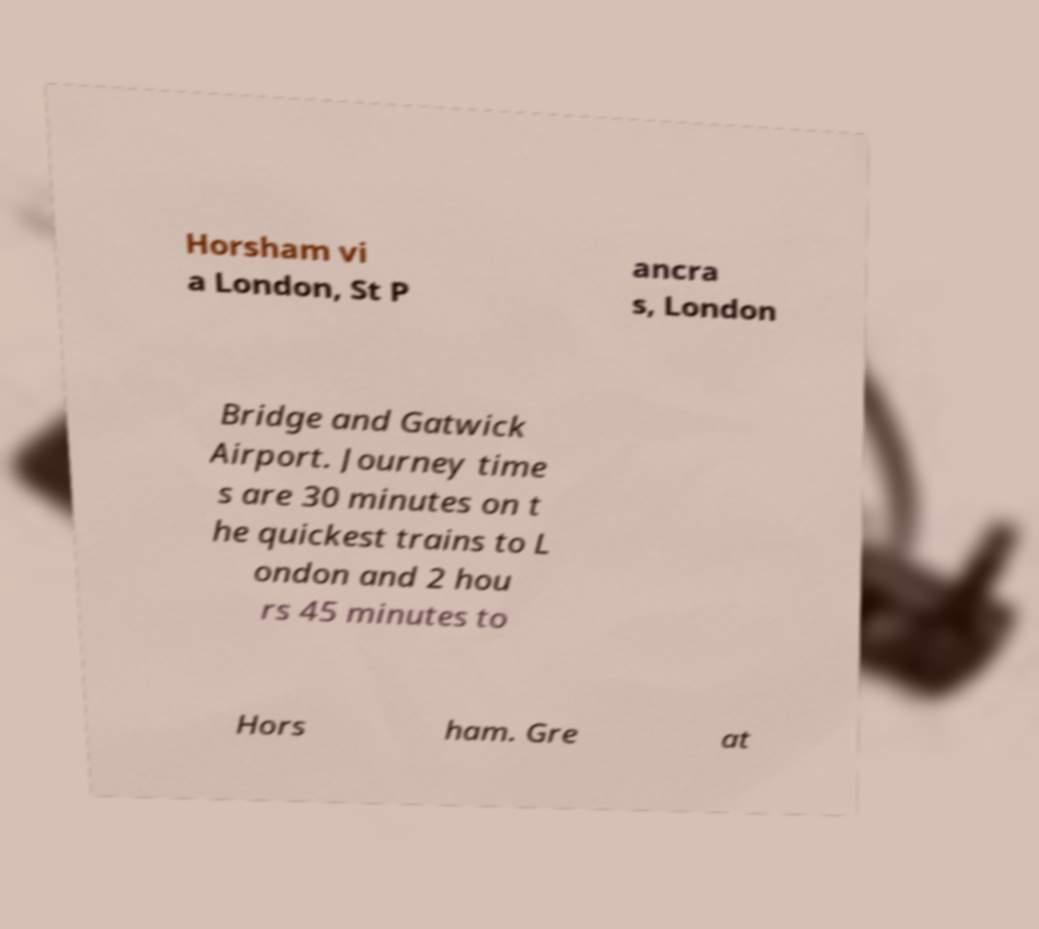There's text embedded in this image that I need extracted. Can you transcribe it verbatim? Horsham vi a London, St P ancra s, London Bridge and Gatwick Airport. Journey time s are 30 minutes on t he quickest trains to L ondon and 2 hou rs 45 minutes to Hors ham. Gre at 